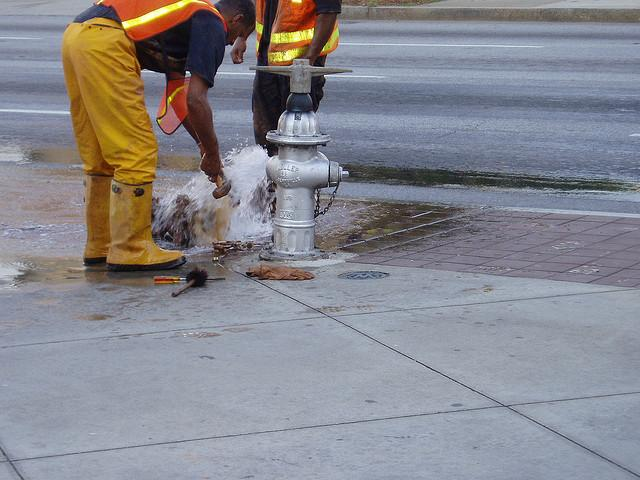Who caused the water to flood out? worker 